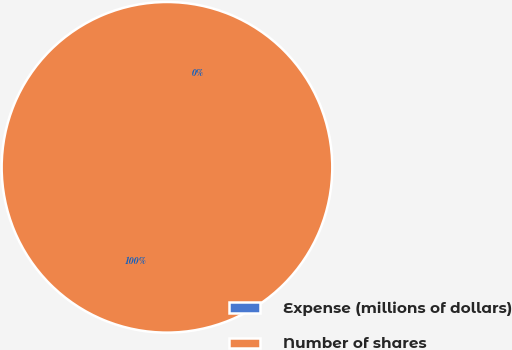Convert chart to OTSL. <chart><loc_0><loc_0><loc_500><loc_500><pie_chart><fcel>Expense (millions of dollars)<fcel>Number of shares<nl><fcel>0.0%<fcel>100.0%<nl></chart> 